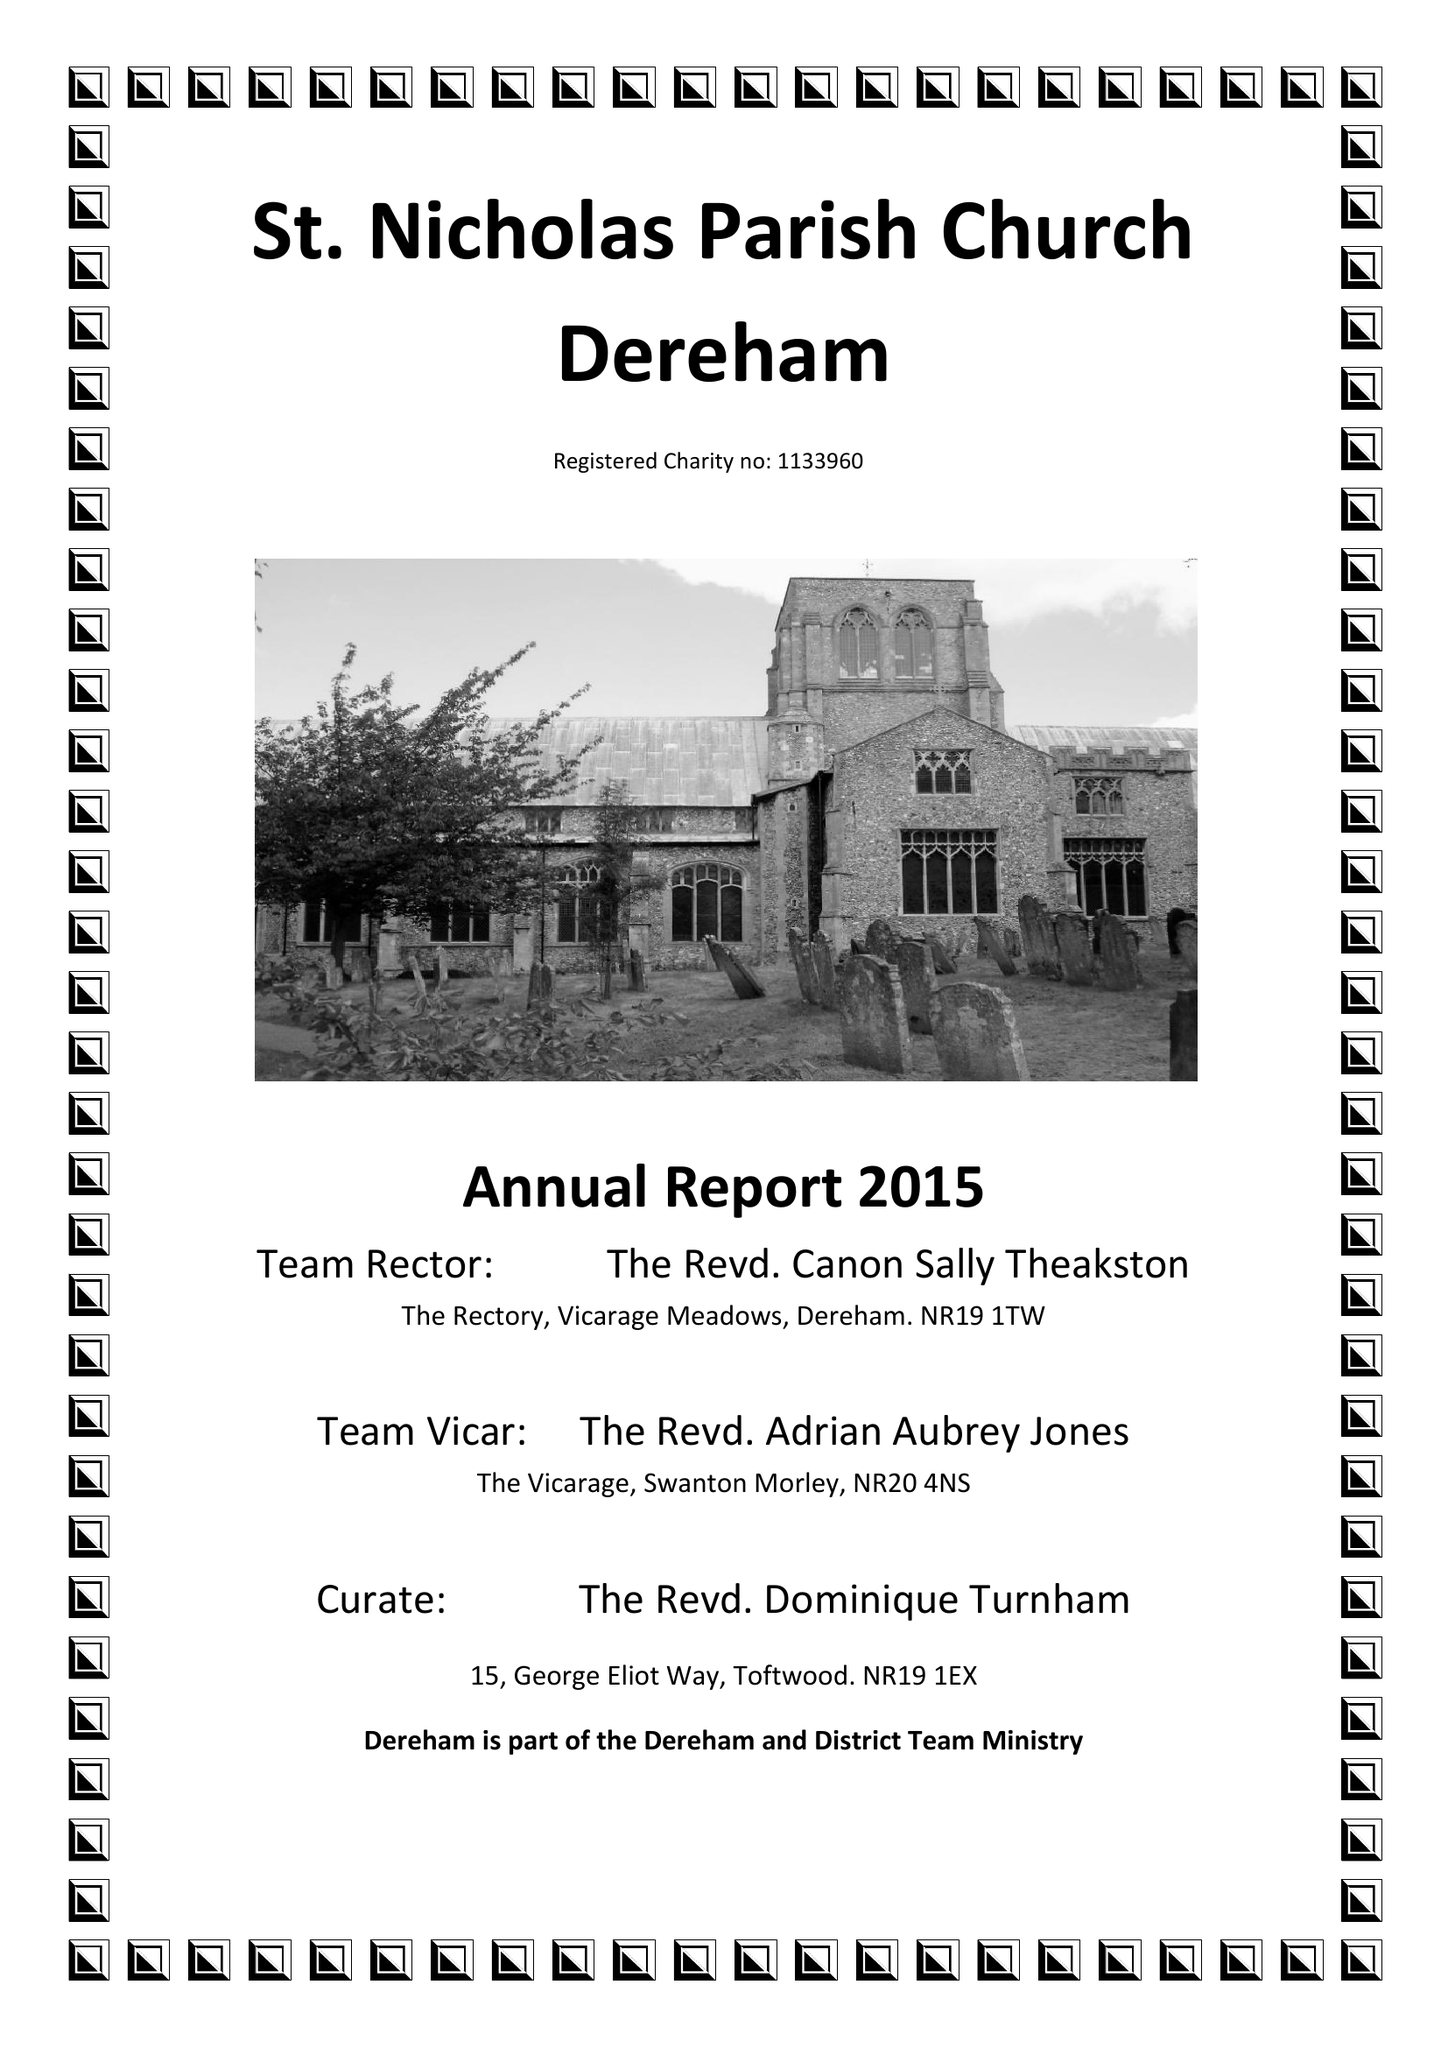What is the value for the spending_annually_in_british_pounds?
Answer the question using a single word or phrase. 109783.00 